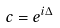Convert formula to latex. <formula><loc_0><loc_0><loc_500><loc_500>c = e ^ { i \Delta }</formula> 